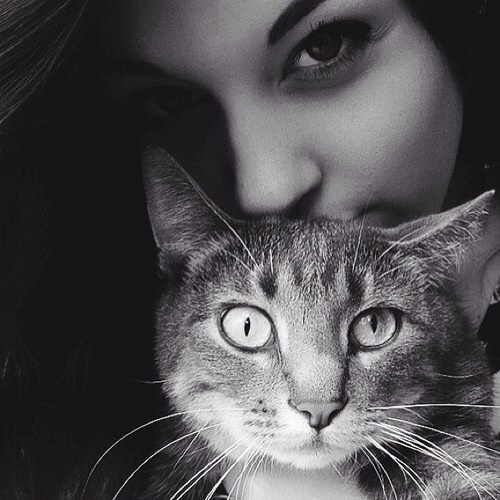Describe the objects in this image and their specific colors. I can see cat in black, gray, darkgray, and lightgray tones and people in black, gray, and darkgray tones in this image. 